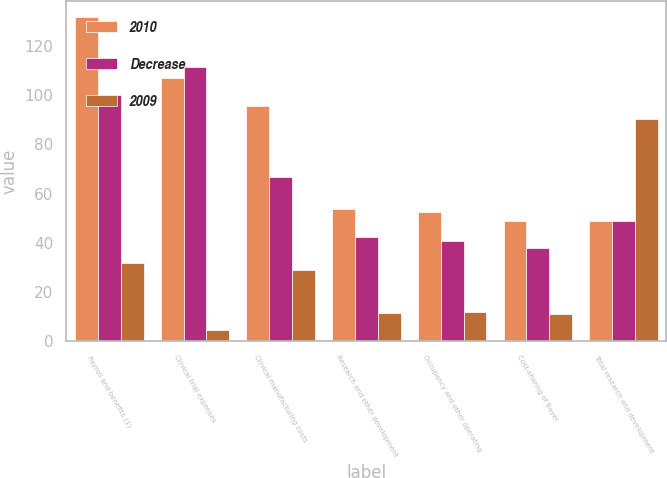<chart> <loc_0><loc_0><loc_500><loc_500><stacked_bar_chart><ecel><fcel>Payroll and benefits (1)<fcel>Clinical trial expenses<fcel>Clinical manufacturing costs<fcel>Research and other development<fcel>Occupancy and other operating<fcel>Cost-sharing of Bayer<fcel>Total research and development<nl><fcel>2010<fcel>131.7<fcel>106.9<fcel>95.6<fcel>53.8<fcel>52.3<fcel>48.9<fcel>48.9<nl><fcel>Decrease<fcel>99.9<fcel>111.6<fcel>66.7<fcel>42.3<fcel>40.6<fcel>37.7<fcel>48.9<nl><fcel>2009<fcel>31.8<fcel>4.7<fcel>28.9<fcel>11.5<fcel>11.7<fcel>11.2<fcel>90.4<nl></chart> 